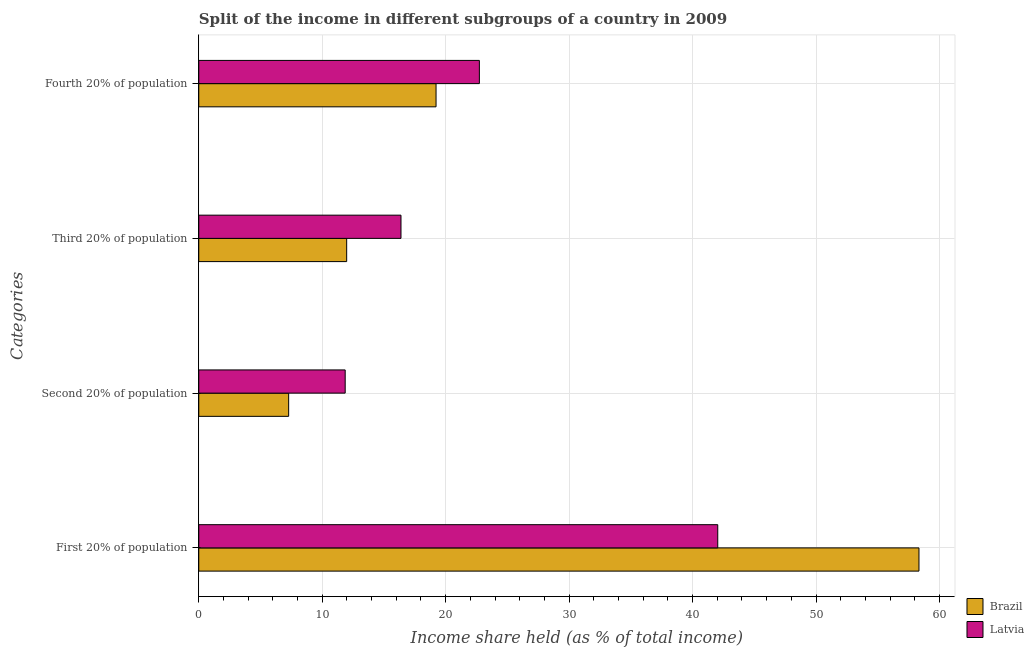How many groups of bars are there?
Offer a terse response. 4. Are the number of bars per tick equal to the number of legend labels?
Offer a very short reply. Yes. What is the label of the 2nd group of bars from the top?
Offer a very short reply. Third 20% of population. What is the share of the income held by fourth 20% of the population in Brazil?
Provide a succinct answer. 19.22. Across all countries, what is the maximum share of the income held by fourth 20% of the population?
Give a very brief answer. 22.73. Across all countries, what is the minimum share of the income held by second 20% of the population?
Your answer should be compact. 7.28. In which country was the share of the income held by first 20% of the population maximum?
Offer a terse response. Brazil. What is the total share of the income held by fourth 20% of the population in the graph?
Provide a succinct answer. 41.95. What is the difference between the share of the income held by first 20% of the population in Brazil and that in Latvia?
Make the answer very short. 16.3. What is the difference between the share of the income held by second 20% of the population in Latvia and the share of the income held by third 20% of the population in Brazil?
Your answer should be compact. -0.12. What is the average share of the income held by first 20% of the population per country?
Your answer should be very brief. 50.19. What is the difference between the share of the income held by second 20% of the population and share of the income held by first 20% of the population in Latvia?
Make the answer very short. -30.18. What is the ratio of the share of the income held by second 20% of the population in Latvia to that in Brazil?
Offer a terse response. 1.63. Is the share of the income held by third 20% of the population in Latvia less than that in Brazil?
Your answer should be very brief. No. What is the difference between the highest and the second highest share of the income held by first 20% of the population?
Your answer should be compact. 16.3. What is the difference between the highest and the lowest share of the income held by fourth 20% of the population?
Your answer should be very brief. 3.51. Is it the case that in every country, the sum of the share of the income held by first 20% of the population and share of the income held by fourth 20% of the population is greater than the sum of share of the income held by third 20% of the population and share of the income held by second 20% of the population?
Ensure brevity in your answer.  Yes. What does the 2nd bar from the top in Fourth 20% of population represents?
Ensure brevity in your answer.  Brazil. What does the 2nd bar from the bottom in First 20% of population represents?
Provide a succinct answer. Latvia. Is it the case that in every country, the sum of the share of the income held by first 20% of the population and share of the income held by second 20% of the population is greater than the share of the income held by third 20% of the population?
Provide a succinct answer. Yes. Are all the bars in the graph horizontal?
Keep it short and to the point. Yes. How many countries are there in the graph?
Provide a succinct answer. 2. What is the difference between two consecutive major ticks on the X-axis?
Keep it short and to the point. 10. How many legend labels are there?
Offer a terse response. 2. What is the title of the graph?
Offer a very short reply. Split of the income in different subgroups of a country in 2009. What is the label or title of the X-axis?
Provide a succinct answer. Income share held (as % of total income). What is the label or title of the Y-axis?
Ensure brevity in your answer.  Categories. What is the Income share held (as % of total income) of Brazil in First 20% of population?
Give a very brief answer. 58.34. What is the Income share held (as % of total income) of Latvia in First 20% of population?
Offer a very short reply. 42.04. What is the Income share held (as % of total income) in Brazil in Second 20% of population?
Provide a short and direct response. 7.28. What is the Income share held (as % of total income) in Latvia in Second 20% of population?
Offer a terse response. 11.86. What is the Income share held (as % of total income) of Brazil in Third 20% of population?
Your response must be concise. 11.98. What is the Income share held (as % of total income) in Latvia in Third 20% of population?
Your answer should be very brief. 16.38. What is the Income share held (as % of total income) in Brazil in Fourth 20% of population?
Your response must be concise. 19.22. What is the Income share held (as % of total income) in Latvia in Fourth 20% of population?
Make the answer very short. 22.73. Across all Categories, what is the maximum Income share held (as % of total income) of Brazil?
Offer a very short reply. 58.34. Across all Categories, what is the maximum Income share held (as % of total income) in Latvia?
Ensure brevity in your answer.  42.04. Across all Categories, what is the minimum Income share held (as % of total income) of Brazil?
Your answer should be compact. 7.28. Across all Categories, what is the minimum Income share held (as % of total income) in Latvia?
Make the answer very short. 11.86. What is the total Income share held (as % of total income) in Brazil in the graph?
Provide a short and direct response. 96.82. What is the total Income share held (as % of total income) in Latvia in the graph?
Offer a very short reply. 93.01. What is the difference between the Income share held (as % of total income) of Brazil in First 20% of population and that in Second 20% of population?
Your answer should be compact. 51.06. What is the difference between the Income share held (as % of total income) of Latvia in First 20% of population and that in Second 20% of population?
Give a very brief answer. 30.18. What is the difference between the Income share held (as % of total income) of Brazil in First 20% of population and that in Third 20% of population?
Make the answer very short. 46.36. What is the difference between the Income share held (as % of total income) in Latvia in First 20% of population and that in Third 20% of population?
Offer a very short reply. 25.66. What is the difference between the Income share held (as % of total income) in Brazil in First 20% of population and that in Fourth 20% of population?
Offer a very short reply. 39.12. What is the difference between the Income share held (as % of total income) in Latvia in First 20% of population and that in Fourth 20% of population?
Your response must be concise. 19.31. What is the difference between the Income share held (as % of total income) of Brazil in Second 20% of population and that in Third 20% of population?
Ensure brevity in your answer.  -4.7. What is the difference between the Income share held (as % of total income) in Latvia in Second 20% of population and that in Third 20% of population?
Give a very brief answer. -4.52. What is the difference between the Income share held (as % of total income) in Brazil in Second 20% of population and that in Fourth 20% of population?
Provide a short and direct response. -11.94. What is the difference between the Income share held (as % of total income) in Latvia in Second 20% of population and that in Fourth 20% of population?
Provide a short and direct response. -10.87. What is the difference between the Income share held (as % of total income) in Brazil in Third 20% of population and that in Fourth 20% of population?
Give a very brief answer. -7.24. What is the difference between the Income share held (as % of total income) in Latvia in Third 20% of population and that in Fourth 20% of population?
Keep it short and to the point. -6.35. What is the difference between the Income share held (as % of total income) in Brazil in First 20% of population and the Income share held (as % of total income) in Latvia in Second 20% of population?
Offer a very short reply. 46.48. What is the difference between the Income share held (as % of total income) in Brazil in First 20% of population and the Income share held (as % of total income) in Latvia in Third 20% of population?
Your answer should be very brief. 41.96. What is the difference between the Income share held (as % of total income) in Brazil in First 20% of population and the Income share held (as % of total income) in Latvia in Fourth 20% of population?
Ensure brevity in your answer.  35.61. What is the difference between the Income share held (as % of total income) in Brazil in Second 20% of population and the Income share held (as % of total income) in Latvia in Third 20% of population?
Provide a succinct answer. -9.1. What is the difference between the Income share held (as % of total income) in Brazil in Second 20% of population and the Income share held (as % of total income) in Latvia in Fourth 20% of population?
Offer a very short reply. -15.45. What is the difference between the Income share held (as % of total income) of Brazil in Third 20% of population and the Income share held (as % of total income) of Latvia in Fourth 20% of population?
Make the answer very short. -10.75. What is the average Income share held (as % of total income) of Brazil per Categories?
Offer a very short reply. 24.2. What is the average Income share held (as % of total income) of Latvia per Categories?
Offer a very short reply. 23.25. What is the difference between the Income share held (as % of total income) in Brazil and Income share held (as % of total income) in Latvia in First 20% of population?
Provide a succinct answer. 16.3. What is the difference between the Income share held (as % of total income) of Brazil and Income share held (as % of total income) of Latvia in Second 20% of population?
Provide a short and direct response. -4.58. What is the difference between the Income share held (as % of total income) of Brazil and Income share held (as % of total income) of Latvia in Third 20% of population?
Your answer should be very brief. -4.4. What is the difference between the Income share held (as % of total income) in Brazil and Income share held (as % of total income) in Latvia in Fourth 20% of population?
Your response must be concise. -3.51. What is the ratio of the Income share held (as % of total income) in Brazil in First 20% of population to that in Second 20% of population?
Offer a terse response. 8.01. What is the ratio of the Income share held (as % of total income) of Latvia in First 20% of population to that in Second 20% of population?
Make the answer very short. 3.54. What is the ratio of the Income share held (as % of total income) in Brazil in First 20% of population to that in Third 20% of population?
Give a very brief answer. 4.87. What is the ratio of the Income share held (as % of total income) in Latvia in First 20% of population to that in Third 20% of population?
Your response must be concise. 2.57. What is the ratio of the Income share held (as % of total income) in Brazil in First 20% of population to that in Fourth 20% of population?
Offer a terse response. 3.04. What is the ratio of the Income share held (as % of total income) of Latvia in First 20% of population to that in Fourth 20% of population?
Your answer should be compact. 1.85. What is the ratio of the Income share held (as % of total income) of Brazil in Second 20% of population to that in Third 20% of population?
Offer a very short reply. 0.61. What is the ratio of the Income share held (as % of total income) in Latvia in Second 20% of population to that in Third 20% of population?
Make the answer very short. 0.72. What is the ratio of the Income share held (as % of total income) of Brazil in Second 20% of population to that in Fourth 20% of population?
Your answer should be compact. 0.38. What is the ratio of the Income share held (as % of total income) in Latvia in Second 20% of population to that in Fourth 20% of population?
Make the answer very short. 0.52. What is the ratio of the Income share held (as % of total income) of Brazil in Third 20% of population to that in Fourth 20% of population?
Offer a very short reply. 0.62. What is the ratio of the Income share held (as % of total income) in Latvia in Third 20% of population to that in Fourth 20% of population?
Provide a succinct answer. 0.72. What is the difference between the highest and the second highest Income share held (as % of total income) in Brazil?
Offer a terse response. 39.12. What is the difference between the highest and the second highest Income share held (as % of total income) of Latvia?
Your response must be concise. 19.31. What is the difference between the highest and the lowest Income share held (as % of total income) of Brazil?
Your answer should be compact. 51.06. What is the difference between the highest and the lowest Income share held (as % of total income) of Latvia?
Offer a terse response. 30.18. 